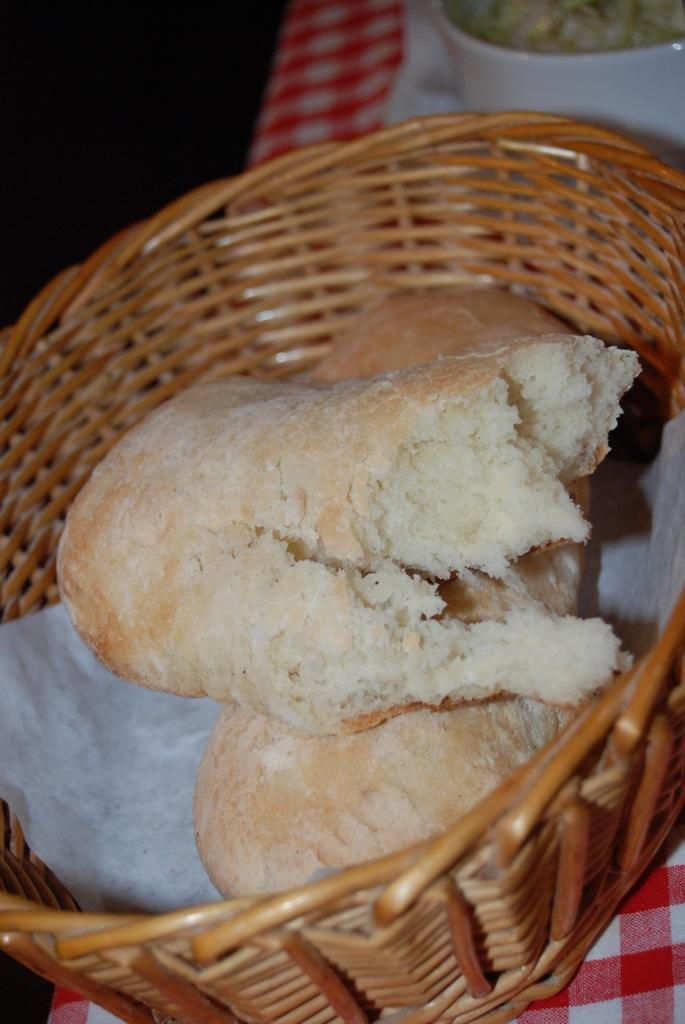What object is present in the image that can hold items? There is a basket in the image. What items are inside the basket? The basket contains two pieces of bread. What is the basket placed on in the image? The basket is placed on a cloth. How many dolls are sitting on the leaf in the image? There are no dolls or leaves present in the image. 